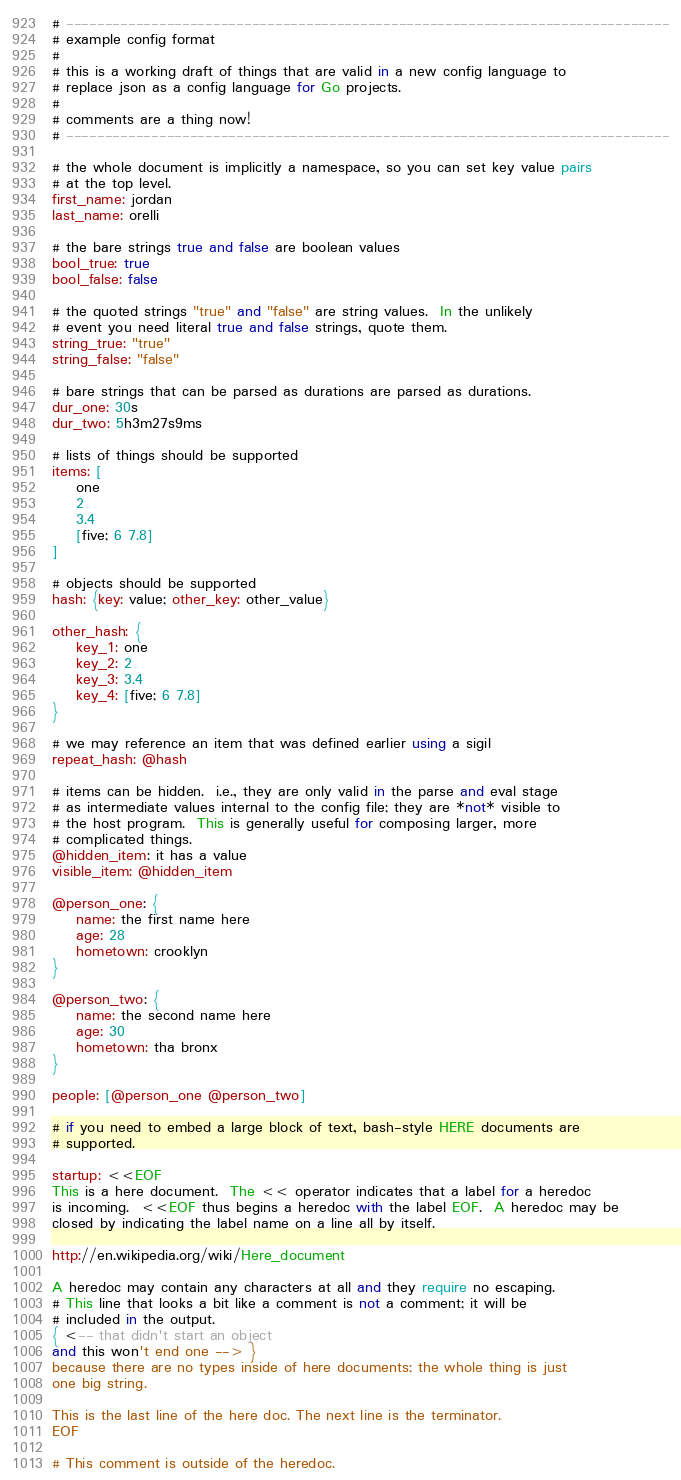<code> <loc_0><loc_0><loc_500><loc_500><_MoonScript_># ------------------------------------------------------------------------------
# example config format
#
# this is a working draft of things that are valid in a new config language to
# replace json as a config language for Go projects.
#
# comments are a thing now!
# ------------------------------------------------------------------------------

# the whole document is implicitly a namespace, so you can set key value pairs
# at the top level.
first_name: jordan
last_name: orelli

# the bare strings true and false are boolean values
bool_true: true
bool_false: false

# the quoted strings "true" and "false" are string values.  In the unlikely
# event you need literal true and false strings, quote them.
string_true: "true"
string_false: "false"

# bare strings that can be parsed as durations are parsed as durations.
dur_one: 30s
dur_two: 5h3m27s9ms

# lists of things should be supported
items: [
    one
    2
    3.4
    [five; 6 7.8]
]

# objects should be supported
hash: {key: value; other_key: other_value}

other_hash: {
    key_1: one
    key_2: 2
    key_3: 3.4
    key_4: [five; 6 7.8]
}

# we may reference an item that was defined earlier using a sigil
repeat_hash: @hash

# items can be hidden.  i.e., they are only valid in the parse and eval stage
# as intermediate values internal to the config file; they are *not* visible to
# the host program.  This is generally useful for composing larger, more
# complicated things.
@hidden_item: it has a value
visible_item: @hidden_item

@person_one: {
    name: the first name here
    age: 28
    hometown: crooklyn
}

@person_two: {
    name: the second name here
    age: 30
    hometown: tha bronx
}

people: [@person_one @person_two]

# if you need to embed a large block of text, bash-style HERE documents are
# supported.

startup: <<EOF
This is a here document.  The << operator indicates that a label for a heredoc
is incoming.  <<EOF thus begins a heredoc with the label EOF.  A heredoc may be
closed by indicating the label name on a line all by itself.

http://en.wikipedia.org/wiki/Here_document

A heredoc may contain any characters at all and they require no escaping.
# This line that looks a bit like a comment is not a comment; it will be
# included in the output.
{ <-- that didn't start an object
and this won't end one --> }
because there are no types inside of here documents; the whole thing is just
one big string.

This is the last line of the here doc. The next line is the terminator.
EOF

# This comment is outside of the heredoc.
</code> 